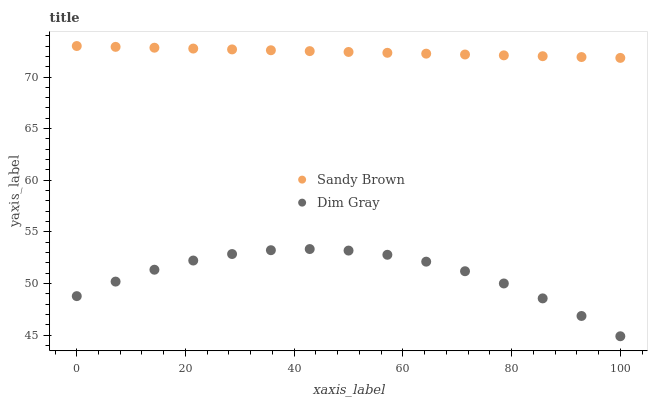Does Dim Gray have the minimum area under the curve?
Answer yes or no. Yes. Does Sandy Brown have the maximum area under the curve?
Answer yes or no. Yes. Does Sandy Brown have the minimum area under the curve?
Answer yes or no. No. Is Sandy Brown the smoothest?
Answer yes or no. Yes. Is Dim Gray the roughest?
Answer yes or no. Yes. Is Sandy Brown the roughest?
Answer yes or no. No. Does Dim Gray have the lowest value?
Answer yes or no. Yes. Does Sandy Brown have the lowest value?
Answer yes or no. No. Does Sandy Brown have the highest value?
Answer yes or no. Yes. Is Dim Gray less than Sandy Brown?
Answer yes or no. Yes. Is Sandy Brown greater than Dim Gray?
Answer yes or no. Yes. Does Dim Gray intersect Sandy Brown?
Answer yes or no. No. 